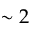<formula> <loc_0><loc_0><loc_500><loc_500>\sim 2</formula> 